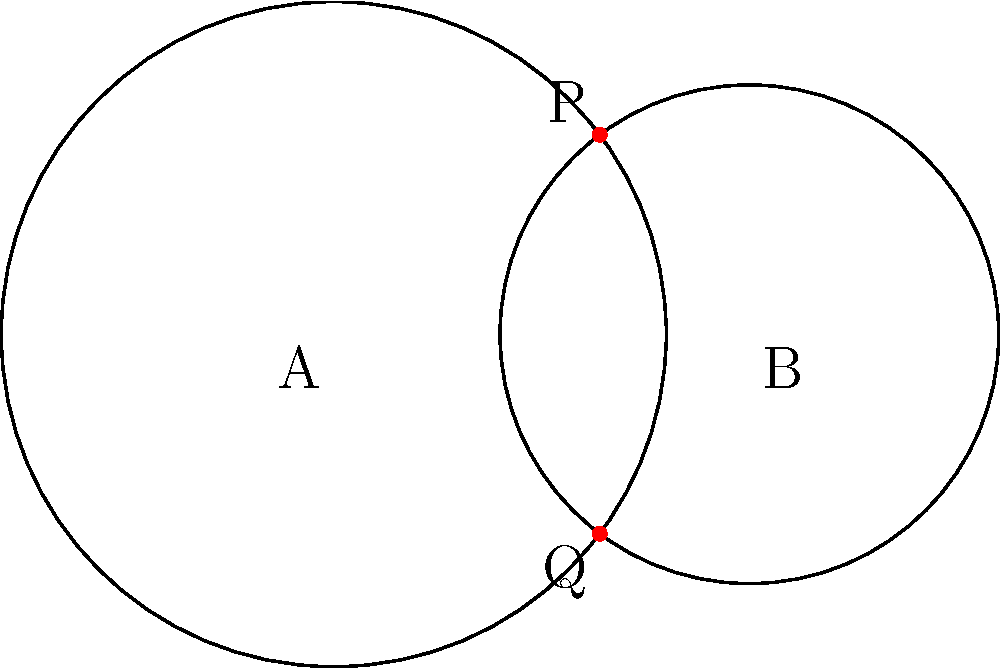Consider the diagram showing two overlapping circles with centers A and B, and radii 0.8 and 0.6 units respectively. The circles intersect at points P and Q. How might the concept of these intersection points serve as a metaphor for the tension between deontological ethics and consequentialism in moral philosophy? Provide a philosophical interpretation of this geometric scenario. To answer this question, let's break down the geometric representation and its philosophical implications:

1. The two circles represent different ethical frameworks:
   - Circle A (larger): Deontological ethics
   - Circle B (smaller): Consequentialism

2. The intersection points P and Q symbolize areas where these ethical frameworks overlap or find common ground.

3. Philosophical interpretation:
   a) Distinct yet overlapping: The circles are separate entities, much like how deontological ethics and consequentialism have distinct foundations. However, they intersect, suggesting that these ethical systems are not entirely incompatible.
   
   b) Limited common ground: The intersection points are small compared to the total area of the circles, indicating that while there are some shared principles or outcomes, the majority of each ethical system remains distinct.
   
   c) Tension and balance: The intersection points can be seen as areas of tension where the two ethical systems must be reconciled. They also represent a potential balance point between duty-based and outcome-based moral reasoning.
   
   d) Multiple solutions: Just as there are two intersection points, ethical dilemmas often have multiple potential resolutions depending on which framework is emphasized.
   
   e) Contextual ethics: The specific location of the intersection points depends on the size and position of the circles. This could represent how the application of ethical principles may vary based on context or situation.

4. Critique of deontological ethics:
   The smaller area of overlap might suggest that deontological ethics, with its focus on absolute moral rules, may have limited flexibility in addressing complex real-world scenarios where consequences also matter.

5. Synthesis potential:
   The existence of intersection points hints at the possibility of developing a more comprehensive ethical framework that incorporates elements from both deontological and consequentialist approaches.

This geometric metaphor illustrates the complexity of ethical reasoning and the potential for finding common ground between seemingly opposing moral philosophies.
Answer: Intersection points represent areas of ethical overlap and tension between deontological ethics and consequentialism, illustrating potential for synthesis and contextual application of moral principles. 